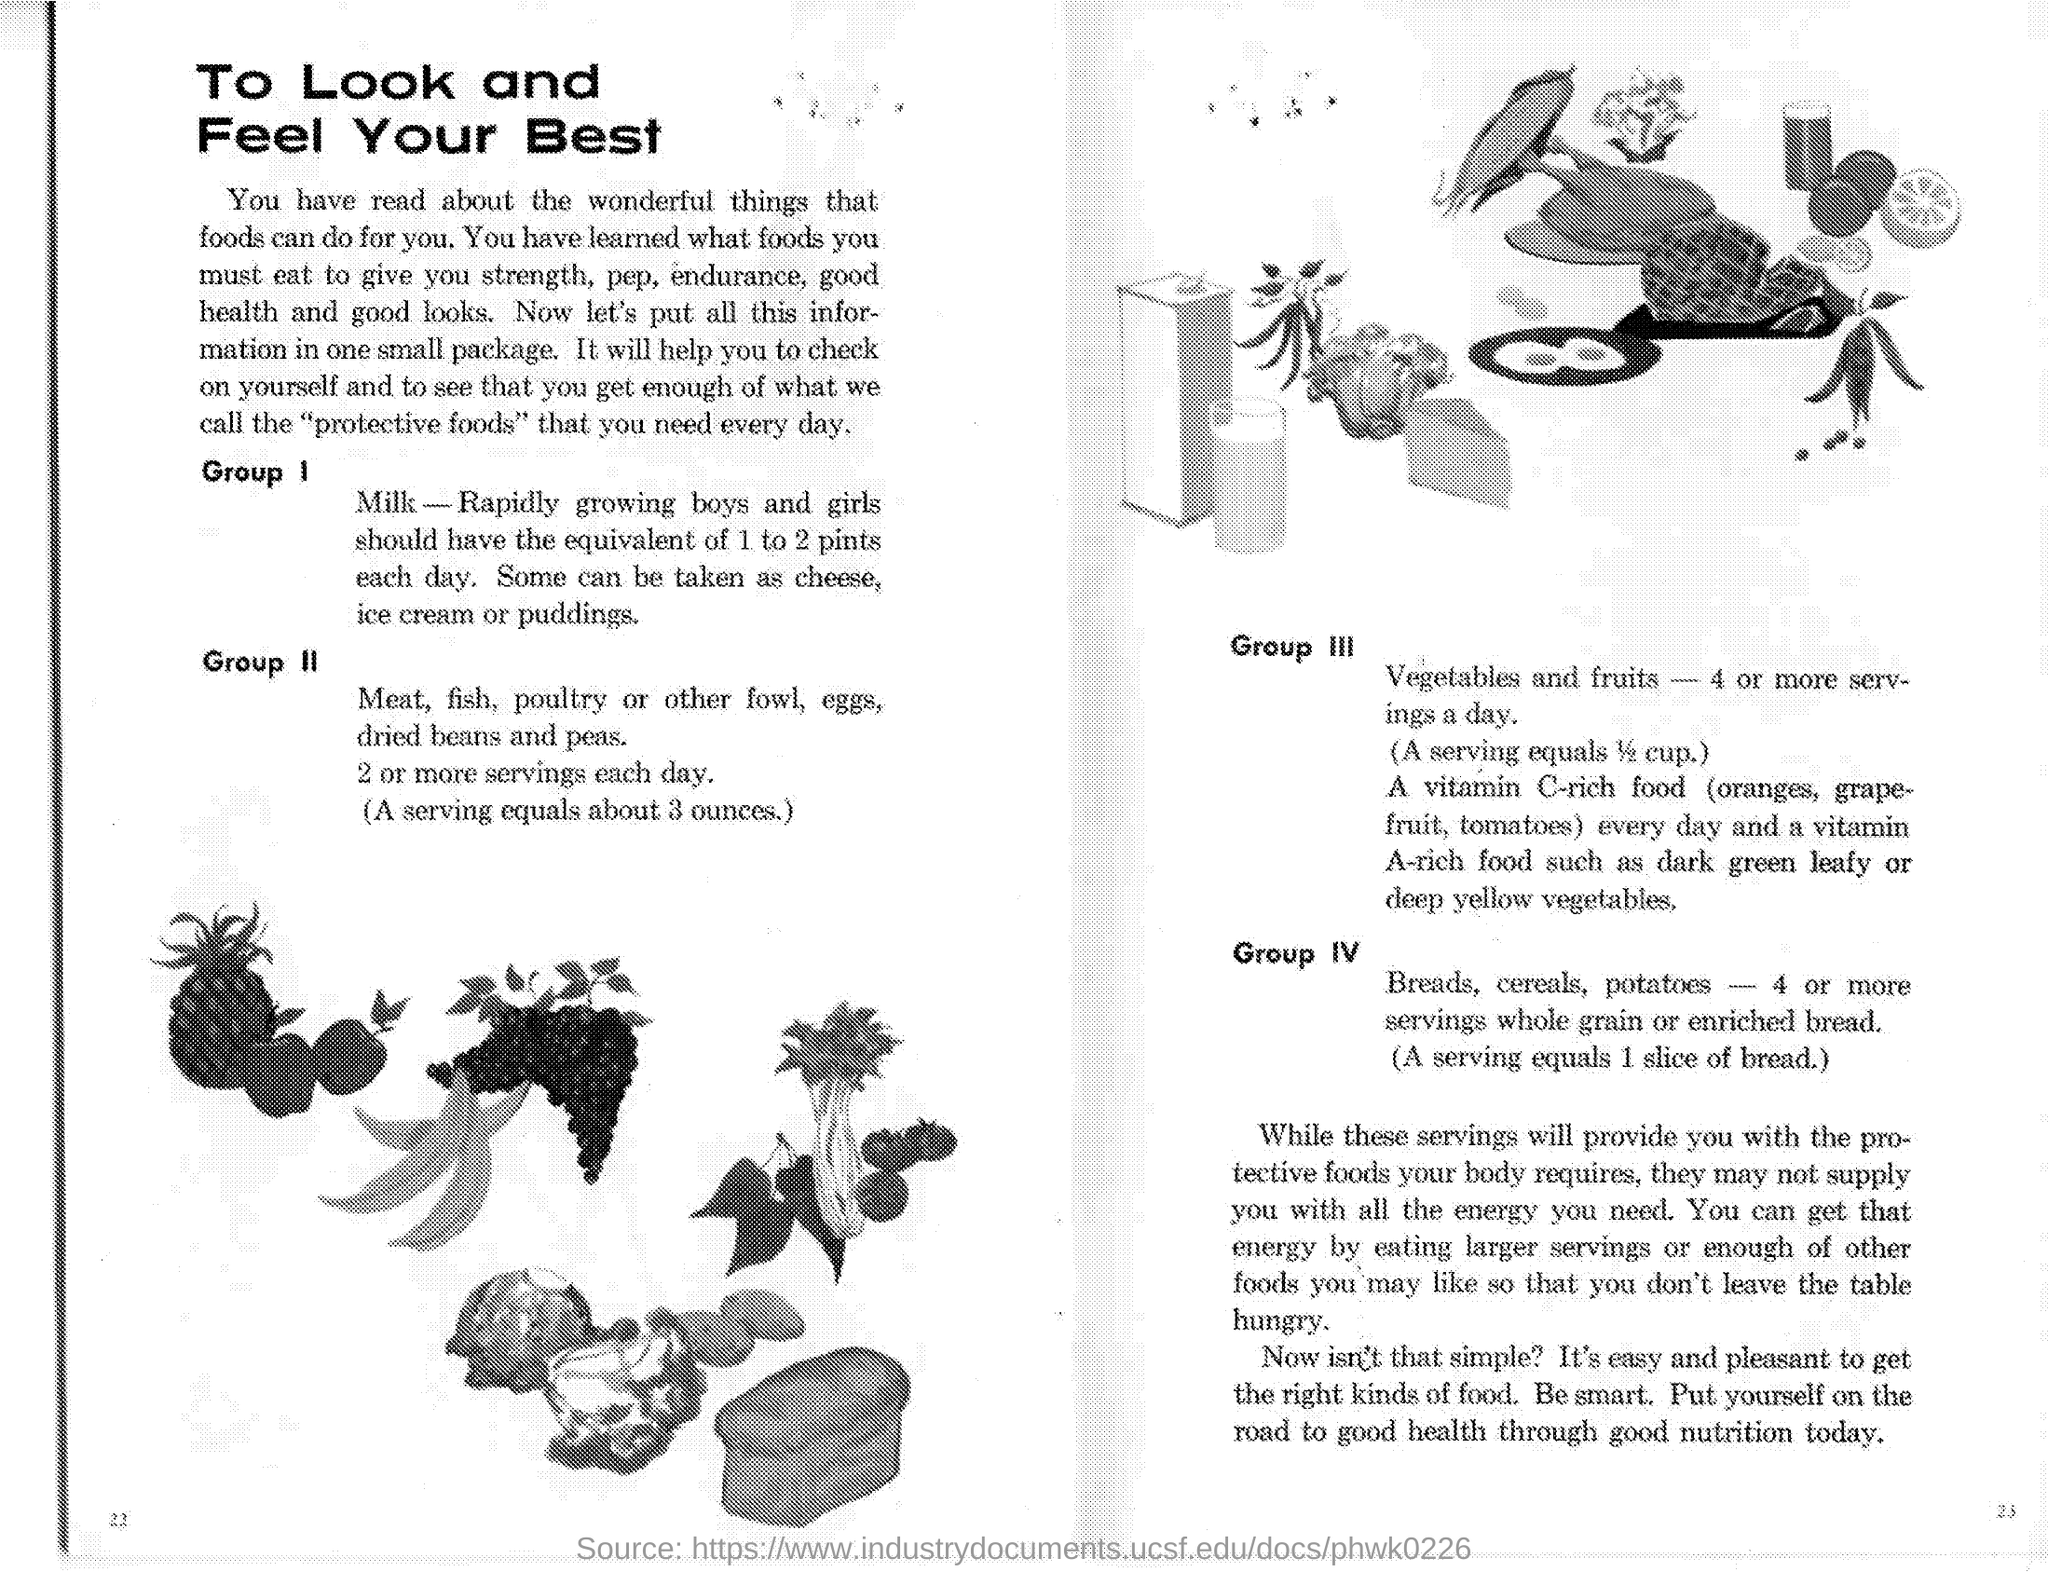What food does Group I contain?
Ensure brevity in your answer.  Milk. How many pints of milk should rapidly growing boys and girls have each day?
Your answer should be compact. 1 to 2 pints. How many ounces does a serving equal?
Keep it short and to the point. About 3 ounces. How many servings of vegetables and fruits are recommended per day?
Make the answer very short. 4 or more servings. 